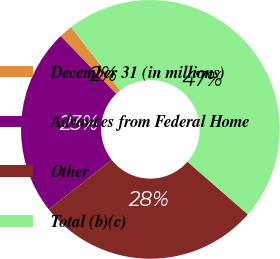Convert chart to OTSL. <chart><loc_0><loc_0><loc_500><loc_500><pie_chart><fcel>December 31 (in millions)<fcel>Advances from Federal Home<fcel>Other<fcel>Total (b)(c)<nl><fcel>1.69%<fcel>23.44%<fcel>27.96%<fcel>46.91%<nl></chart> 